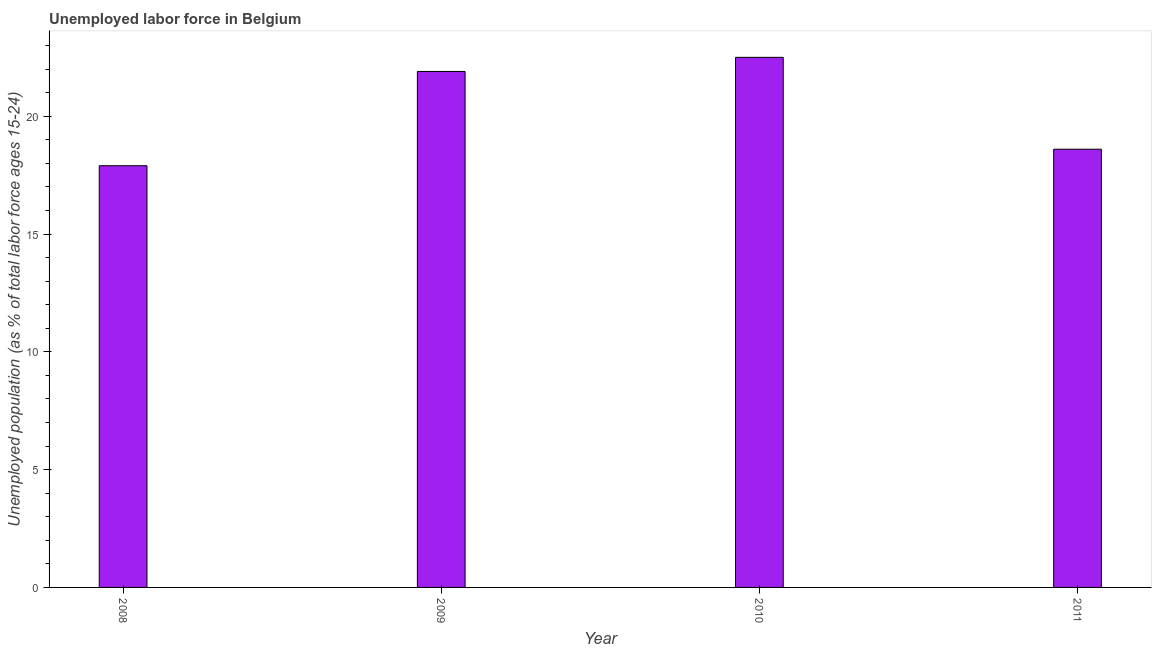Does the graph contain grids?
Provide a short and direct response. No. What is the title of the graph?
Provide a succinct answer. Unemployed labor force in Belgium. What is the label or title of the Y-axis?
Your answer should be very brief. Unemployed population (as % of total labor force ages 15-24). What is the total unemployed youth population in 2011?
Your answer should be compact. 18.6. Across all years, what is the minimum total unemployed youth population?
Make the answer very short. 17.9. In which year was the total unemployed youth population maximum?
Give a very brief answer. 2010. What is the sum of the total unemployed youth population?
Your answer should be very brief. 80.9. What is the difference between the total unemployed youth population in 2008 and 2010?
Make the answer very short. -4.6. What is the average total unemployed youth population per year?
Give a very brief answer. 20.23. What is the median total unemployed youth population?
Make the answer very short. 20.25. What is the ratio of the total unemployed youth population in 2008 to that in 2010?
Ensure brevity in your answer.  0.8. Is the total unemployed youth population in 2008 less than that in 2010?
Your answer should be very brief. Yes. What is the difference between the highest and the second highest total unemployed youth population?
Keep it short and to the point. 0.6. Is the sum of the total unemployed youth population in 2009 and 2010 greater than the maximum total unemployed youth population across all years?
Keep it short and to the point. Yes. What is the difference between the highest and the lowest total unemployed youth population?
Ensure brevity in your answer.  4.6. How many bars are there?
Ensure brevity in your answer.  4. Are all the bars in the graph horizontal?
Make the answer very short. No. What is the difference between two consecutive major ticks on the Y-axis?
Ensure brevity in your answer.  5. What is the Unemployed population (as % of total labor force ages 15-24) of 2008?
Ensure brevity in your answer.  17.9. What is the Unemployed population (as % of total labor force ages 15-24) in 2009?
Offer a very short reply. 21.9. What is the Unemployed population (as % of total labor force ages 15-24) in 2010?
Keep it short and to the point. 22.5. What is the Unemployed population (as % of total labor force ages 15-24) in 2011?
Make the answer very short. 18.6. What is the difference between the Unemployed population (as % of total labor force ages 15-24) in 2009 and 2010?
Your answer should be compact. -0.6. What is the ratio of the Unemployed population (as % of total labor force ages 15-24) in 2008 to that in 2009?
Keep it short and to the point. 0.82. What is the ratio of the Unemployed population (as % of total labor force ages 15-24) in 2008 to that in 2010?
Your response must be concise. 0.8. What is the ratio of the Unemployed population (as % of total labor force ages 15-24) in 2008 to that in 2011?
Provide a short and direct response. 0.96. What is the ratio of the Unemployed population (as % of total labor force ages 15-24) in 2009 to that in 2010?
Make the answer very short. 0.97. What is the ratio of the Unemployed population (as % of total labor force ages 15-24) in 2009 to that in 2011?
Give a very brief answer. 1.18. What is the ratio of the Unemployed population (as % of total labor force ages 15-24) in 2010 to that in 2011?
Make the answer very short. 1.21. 